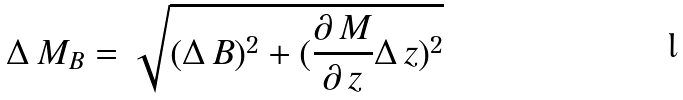<formula> <loc_0><loc_0><loc_500><loc_500>\Delta \, M _ { B } = \sqrt { ( \Delta \, B ) ^ { 2 } + ( \frac { \partial \, M } { \partial \, z } \Delta \, z ) ^ { 2 } }</formula> 